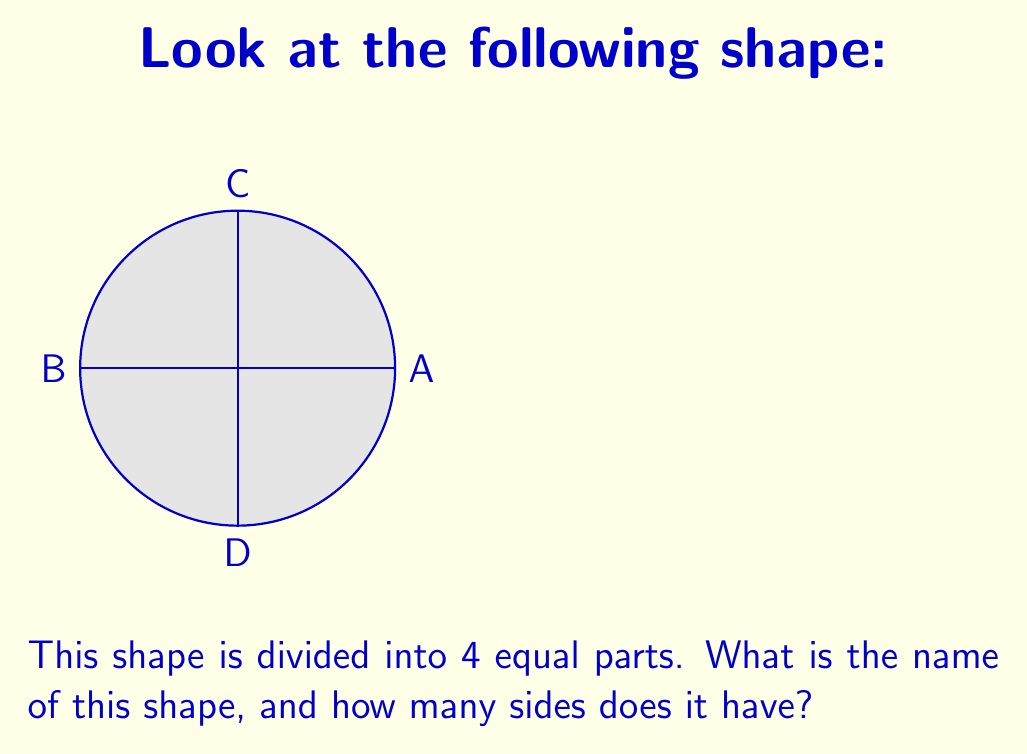Show me your answer to this math problem. Let's break this down step-by-step:

1. First, we need to identify the overall shape. The shape is round and has a curved edge all the way around. This is the defining characteristic of a circle.

2. To confirm it's a circle, we can see that all points on the edge are equidistant from the center. Points A, B, C, and D are all the same distance from the center.

3. The question asks how many sides this shape has. In geometry, a side is a straight line segment that forms part of the shape's boundary. 

4. A circle is a unique shape because it has no straight sides. Its boundary is one continuous curved line.

5. Therefore, we can say that a circle has 0 sides.

So, the shape is a circle, and it has 0 sides.
Answer: Circle, 0 sides 